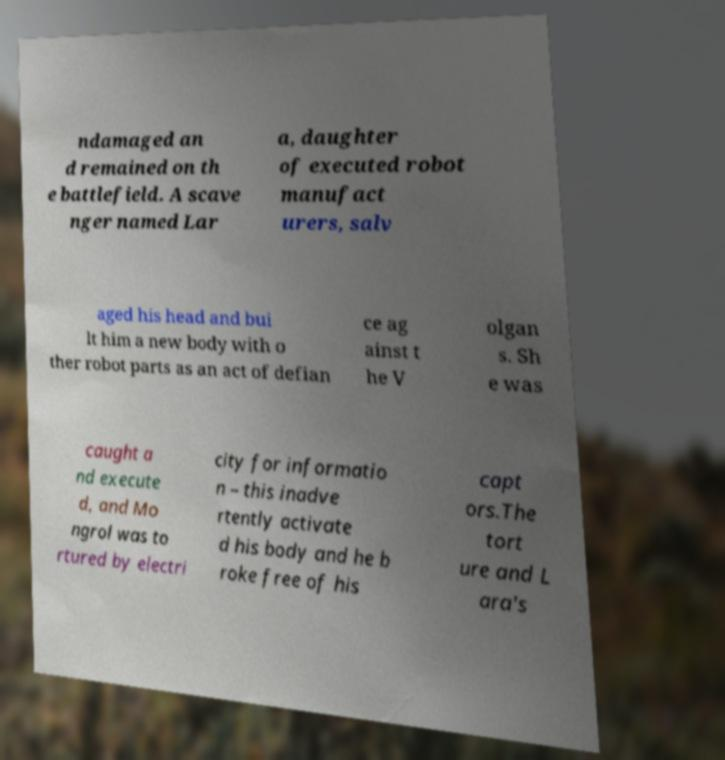Can you read and provide the text displayed in the image?This photo seems to have some interesting text. Can you extract and type it out for me? ndamaged an d remained on th e battlefield. A scave nger named Lar a, daughter of executed robot manufact urers, salv aged his head and bui lt him a new body with o ther robot parts as an act of defian ce ag ainst t he V olgan s. Sh e was caught a nd execute d, and Mo ngrol was to rtured by electri city for informatio n – this inadve rtently activate d his body and he b roke free of his capt ors.The tort ure and L ara's 